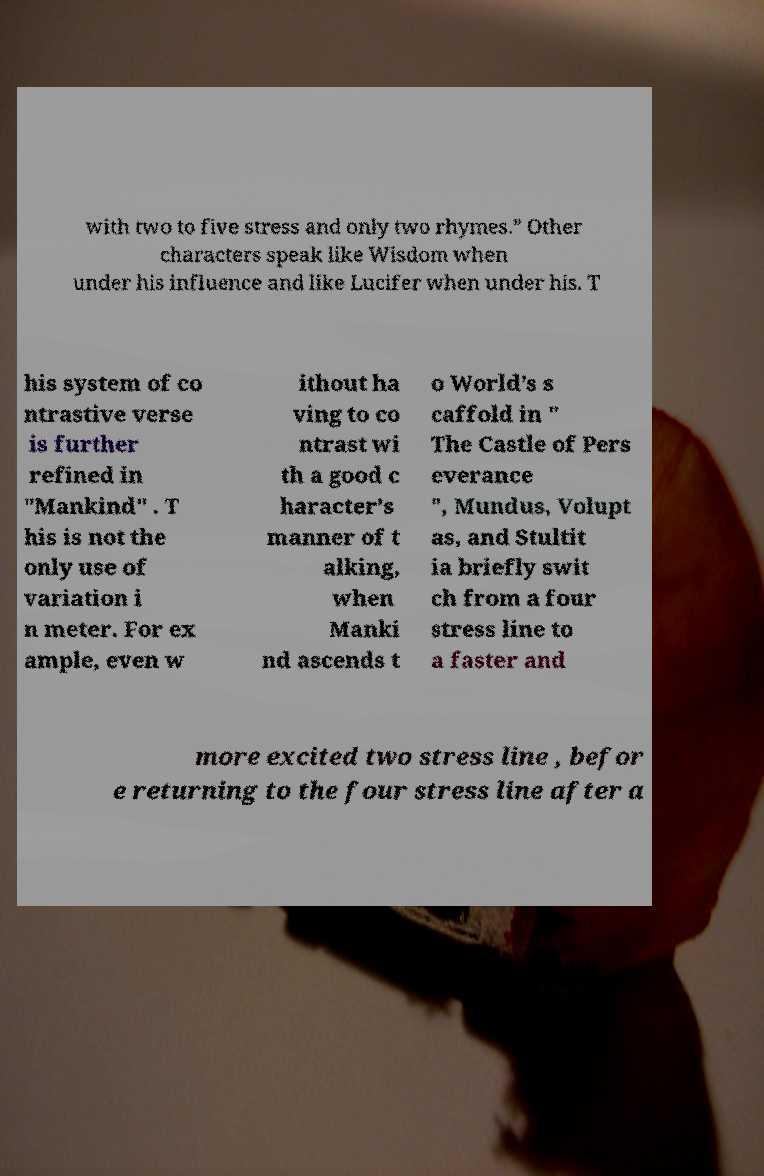Can you read and provide the text displayed in the image?This photo seems to have some interesting text. Can you extract and type it out for me? with two to five stress and only two rhymes.” Other characters speak like Wisdom when under his influence and like Lucifer when under his. T his system of co ntrastive verse is further refined in "Mankind" . T his is not the only use of variation i n meter. For ex ample, even w ithout ha ving to co ntrast wi th a good c haracter’s manner of t alking, when Manki nd ascends t o World’s s caffold in " The Castle of Pers everance ", Mundus, Volupt as, and Stultit ia briefly swit ch from a four stress line to a faster and more excited two stress line , befor e returning to the four stress line after a 